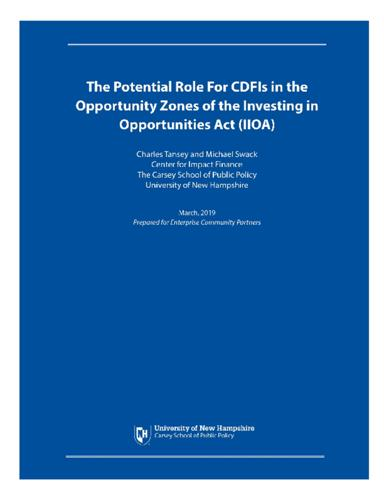What is the topic of the document mentioned in the image? The document focuses on exploring the strategic involvement of Community Development Financial Institutions (CDFIs) within the newly designated Opportunity Zones created by the Investing in Opportunities Act (IIOA). 